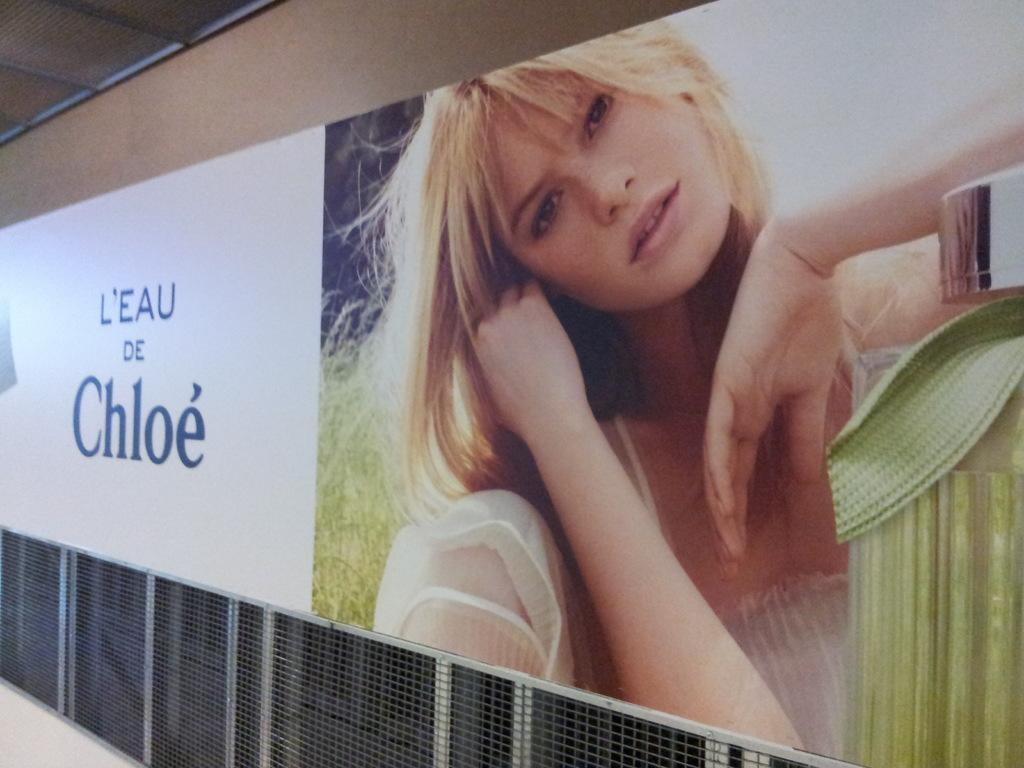What is the main object in the center of the image? There is a board in the center of the image. Where is the board located? The board is placed on a wall. What can be seen at the bottom of the image? There is a mesh at the bottom of the image. What type of work is being done in the image? There is no indication of any work being done in the image; it primarily features a board on a wall and a mesh at the bottom. 